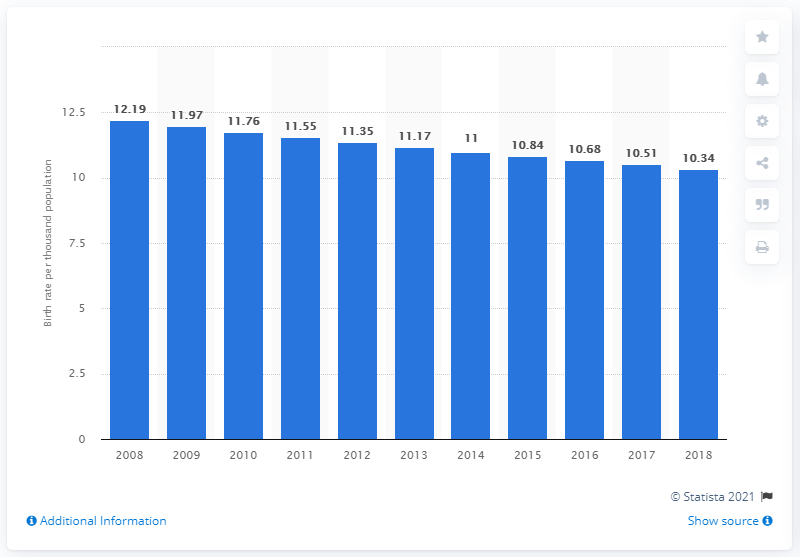Indicate a few pertinent items in this graphic. In 2018, the crude birth rate in Thailand was 10.34. 